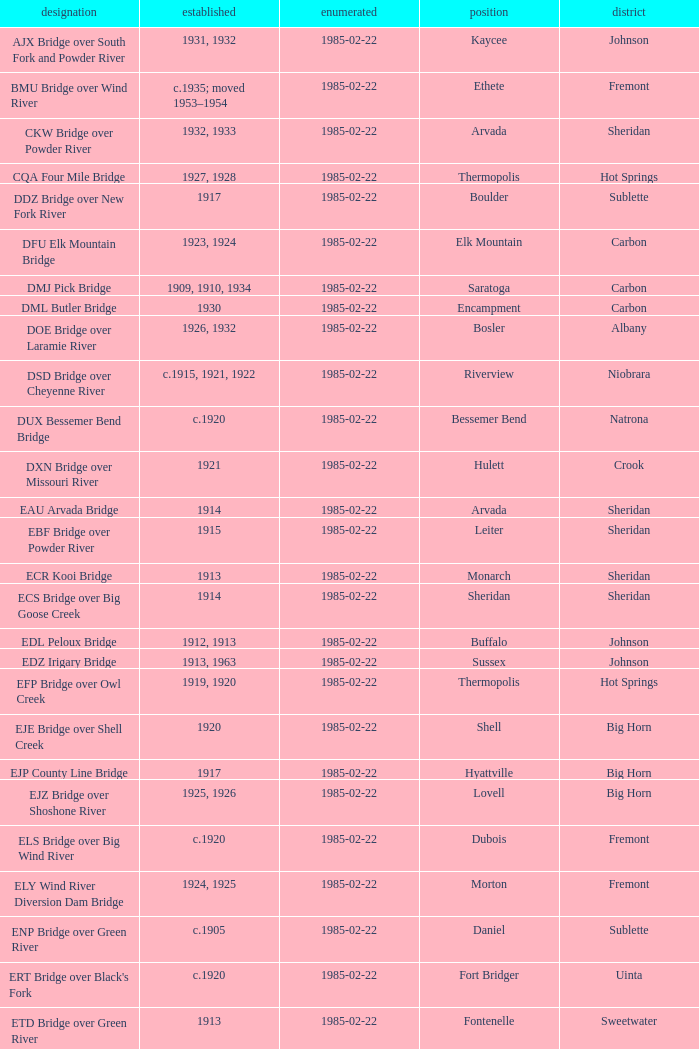In sheridan county, what is the name of the bridge built in 1915? EBF Bridge over Powder River. 